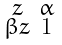Convert formula to latex. <formula><loc_0><loc_0><loc_500><loc_500>\begin{smallmatrix} z & \alpha \\ \beta z & 1 \end{smallmatrix}</formula> 